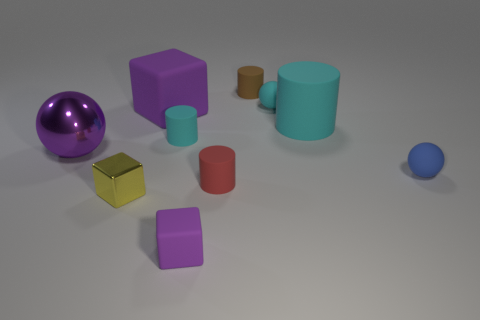Are there any brown matte objects that have the same shape as the tiny red matte thing?
Ensure brevity in your answer.  Yes. Do the purple matte object behind the blue ball and the blue object that is in front of the purple metal thing have the same shape?
Your answer should be compact. No. What shape is the object that is both left of the large block and behind the yellow shiny object?
Provide a short and direct response. Sphere. Is there a green ball that has the same size as the brown cylinder?
Keep it short and to the point. No. There is a large matte cube; is its color the same as the shiny thing in front of the purple sphere?
Give a very brief answer. No. What material is the blue ball?
Offer a terse response. Rubber. The large matte object that is left of the small purple rubber cube is what color?
Give a very brief answer. Purple. How many other cylinders are the same color as the big rubber cylinder?
Make the answer very short. 1. What number of small rubber balls are both behind the small blue rubber ball and right of the cyan ball?
Make the answer very short. 0. What shape is the yellow metal thing that is the same size as the blue ball?
Make the answer very short. Cube. 